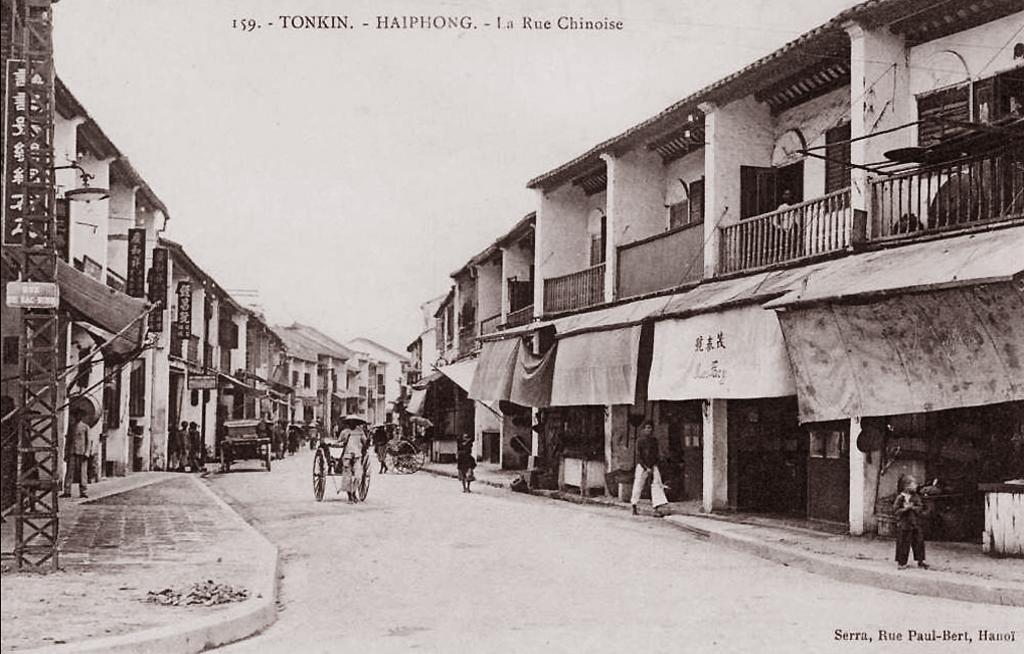Please provide a concise description of this image. In this picture I can see the building. On the road I can see many peoples were standing near to the cars and chariot. On the left I can see the electric pole. At the top I can see the sky. In the bottom right corner I can see the watermark. On the right I can see the balcony, railing, banners and other objects. 